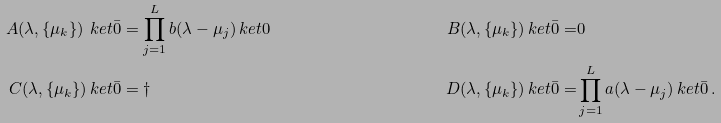<formula> <loc_0><loc_0><loc_500><loc_500>A ( \lambda , \{ \mu _ { k } \} ) \ k e t { \bar { 0 } } & = \prod _ { j = 1 } ^ { L } b ( \lambda - \mu _ { j } ) \ k e t { 0 } & B ( \lambda , \{ \mu _ { k } \} ) \ k e t { \bar { 0 } } = & 0 \\ C ( \lambda , \{ \mu _ { k } \} ) \ k e t { \bar { 0 } } & = \dagger & D ( \lambda , \{ \mu _ { k } \} ) \ k e t { \bar { 0 } } = & \prod _ { j = 1 } ^ { L } a ( \lambda - \mu _ { j } ) \ k e t { \bar { 0 } } \, .</formula> 